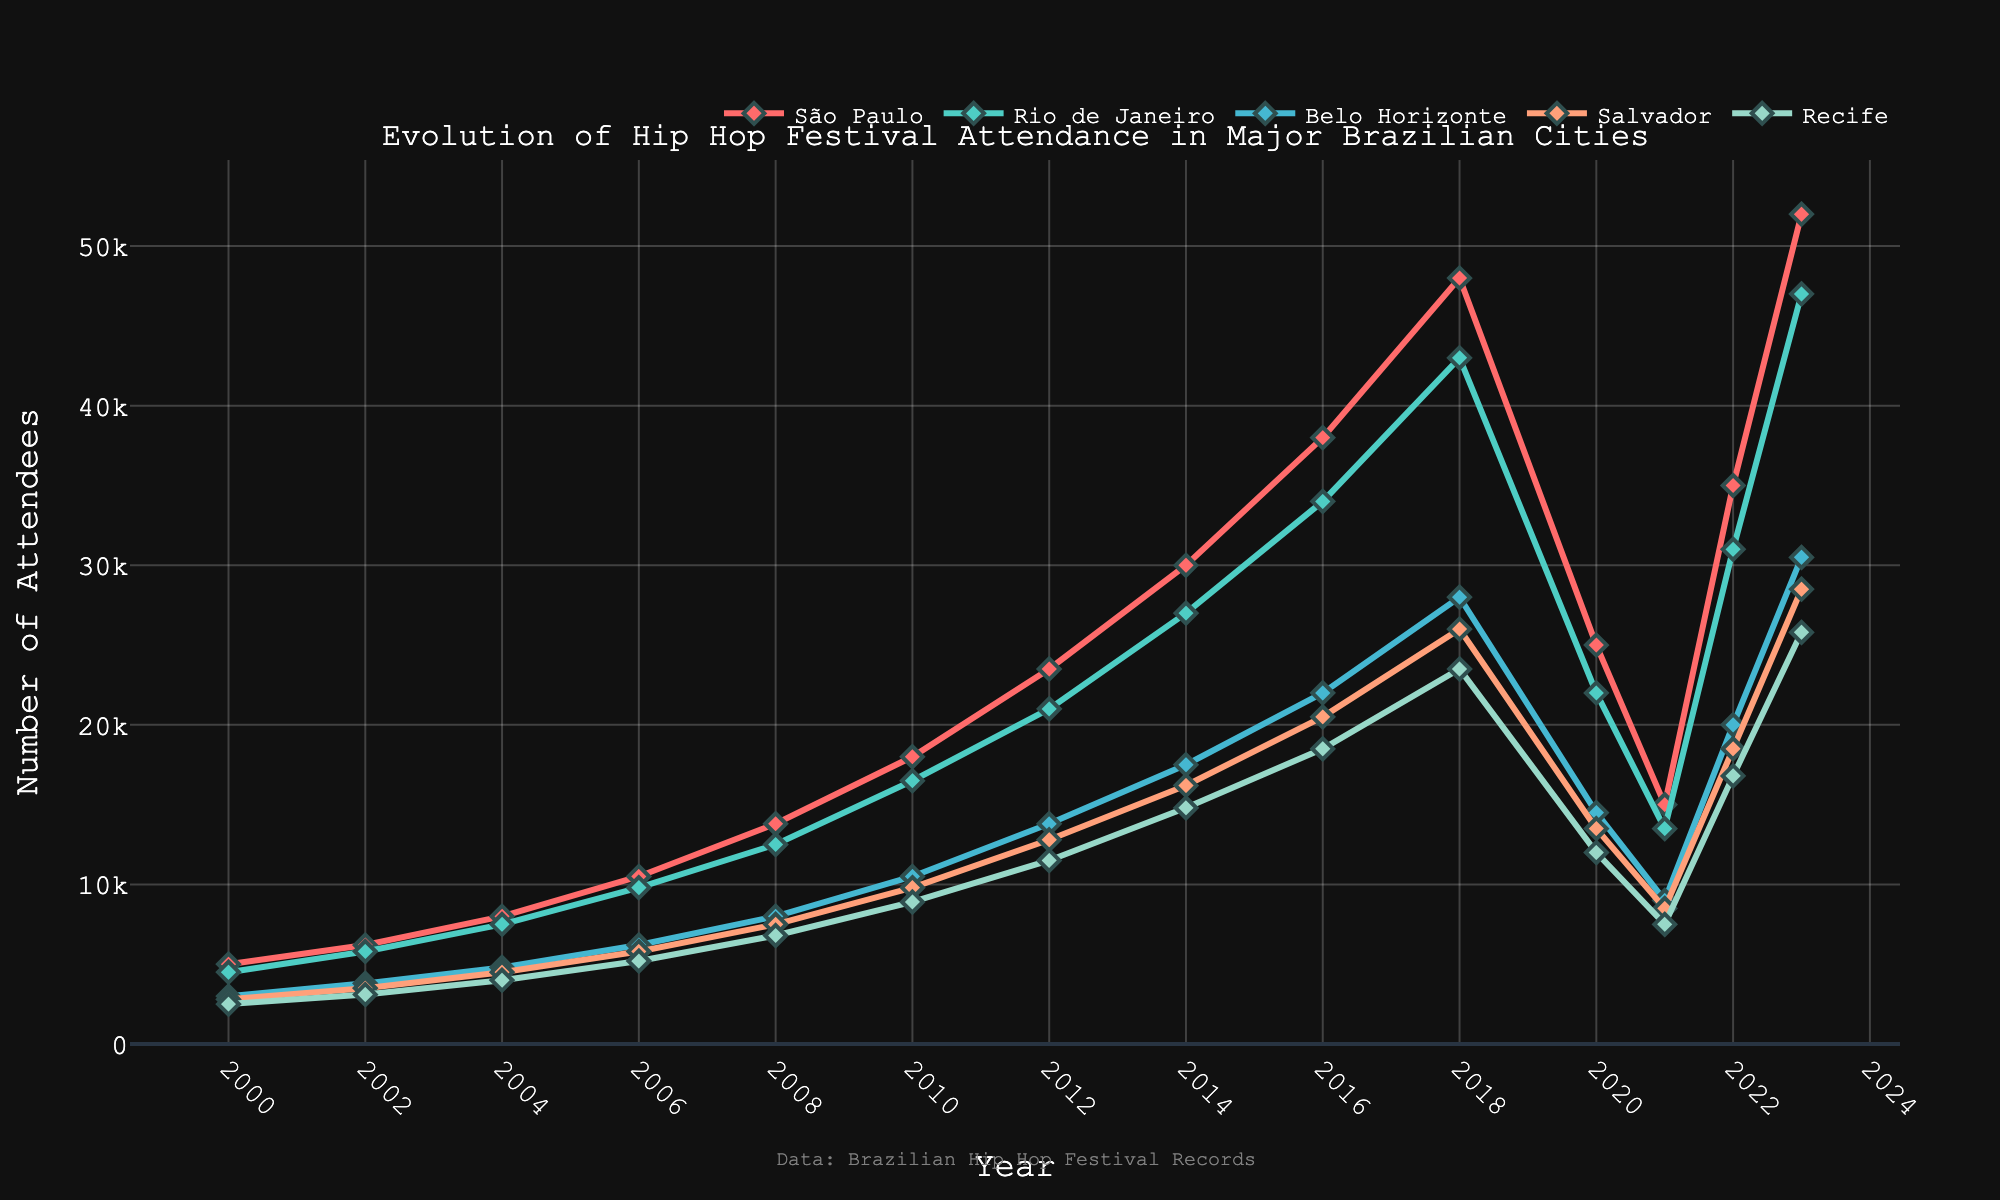What's the trend in hip hop festival attendance in São Paulo from 2000 to 2023? The attendance in São Paulo has generally increased from 2000 to 2023. There are slight declines in the years 2020 and 2021, but the overall trend is upward.
Answer: Upward trend In which year did Rio de Janeiro see its highest hip hop festival attendance? By looking at the peak point for Rio de Janeiro on the chart, we can see that the year with the highest attendance is 2023.
Answer: 2023 Comparing years 2010 and 2023, how much did festival attendance in Belo Horizonte increase? In 2010, the attendance in Belo Horizonte was 10,500. In 2023, it was 30,500. The difference is 30,500 - 10,500 = 20,000.
Answer: 20,000 Which city had the lowest attendance in 2021 and how many attendees were there? In 2021, Recife had the lowest attendance. By consulting the chart, we see the value for Recife in 2021 is 7,500.
Answer: Recife, 7,500 attendees What's the color of the line representing Salvador's festival attendance? The color of the line for Salvador's festival attendance appears as a shade of orange.
Answer: Orange Calculate the average attendance for Recife across all listed years. To find the average attendance, sum up the values for Recife (2500 + 3100 + 4000 + 5200 + 6800 + 8900 + 11500 + 14800 + 18500 + 23500 + 12000 + 7500 + 16800 + 25800 = 158200) and divide by the number of years (14). The average is 158200 / 14 = 11300.
Answer: 11300 Which year had the largest drop in attendance for São Paulo and by how many attendees? We can compare each consecutive year's attendance to find the largest drop. The largest drop happens between 2018 and 2020, from 48,000 to 25,000. The drop is 48,000 - 25,000 = 23,000.
Answer: 2018 to 2020, 23,000 In which year did Rio de Janeiro and Salvador have the same number of attendees? By comparing the values for each year, we find that Rio de Janeiro and Salvador had the same number of attendees (18,500) in 2022.
Answer: 2022 What is the increase in attendees for Salvador from 2006 to 2018? The attendance in Salvador was 5,800 in 2006 and 26,000 in 2018. The increase is 26,000 - 5,800 = 20,200.
Answer: 20,200 